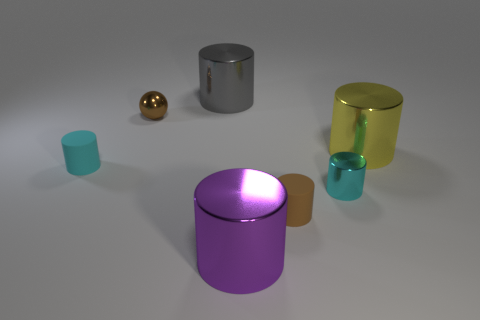Are the small brown thing that is on the right side of the gray shiny cylinder and the large gray cylinder made of the same material?
Ensure brevity in your answer.  No. What material is the tiny cyan object that is to the left of the rubber object that is in front of the cyan object that is in front of the tiny cyan matte cylinder?
Offer a terse response. Rubber. What number of other objects are there of the same shape as the yellow thing?
Your answer should be very brief. 5. There is a sphere left of the big gray metal thing; what color is it?
Keep it short and to the point. Brown. How many small brown cylinders are behind the large cylinder to the right of the small cyan object that is to the right of the tiny brown metallic ball?
Your response must be concise. 0. What number of things are on the right side of the big object behind the shiny sphere?
Your answer should be compact. 4. How many small cyan shiny things are left of the tiny brown shiny ball?
Ensure brevity in your answer.  0. What number of other objects are there of the same size as the brown shiny ball?
Ensure brevity in your answer.  3. What size is the gray object that is the same shape as the cyan shiny object?
Offer a very short reply. Large. The small metal thing that is behind the large yellow cylinder has what shape?
Your answer should be compact. Sphere. 